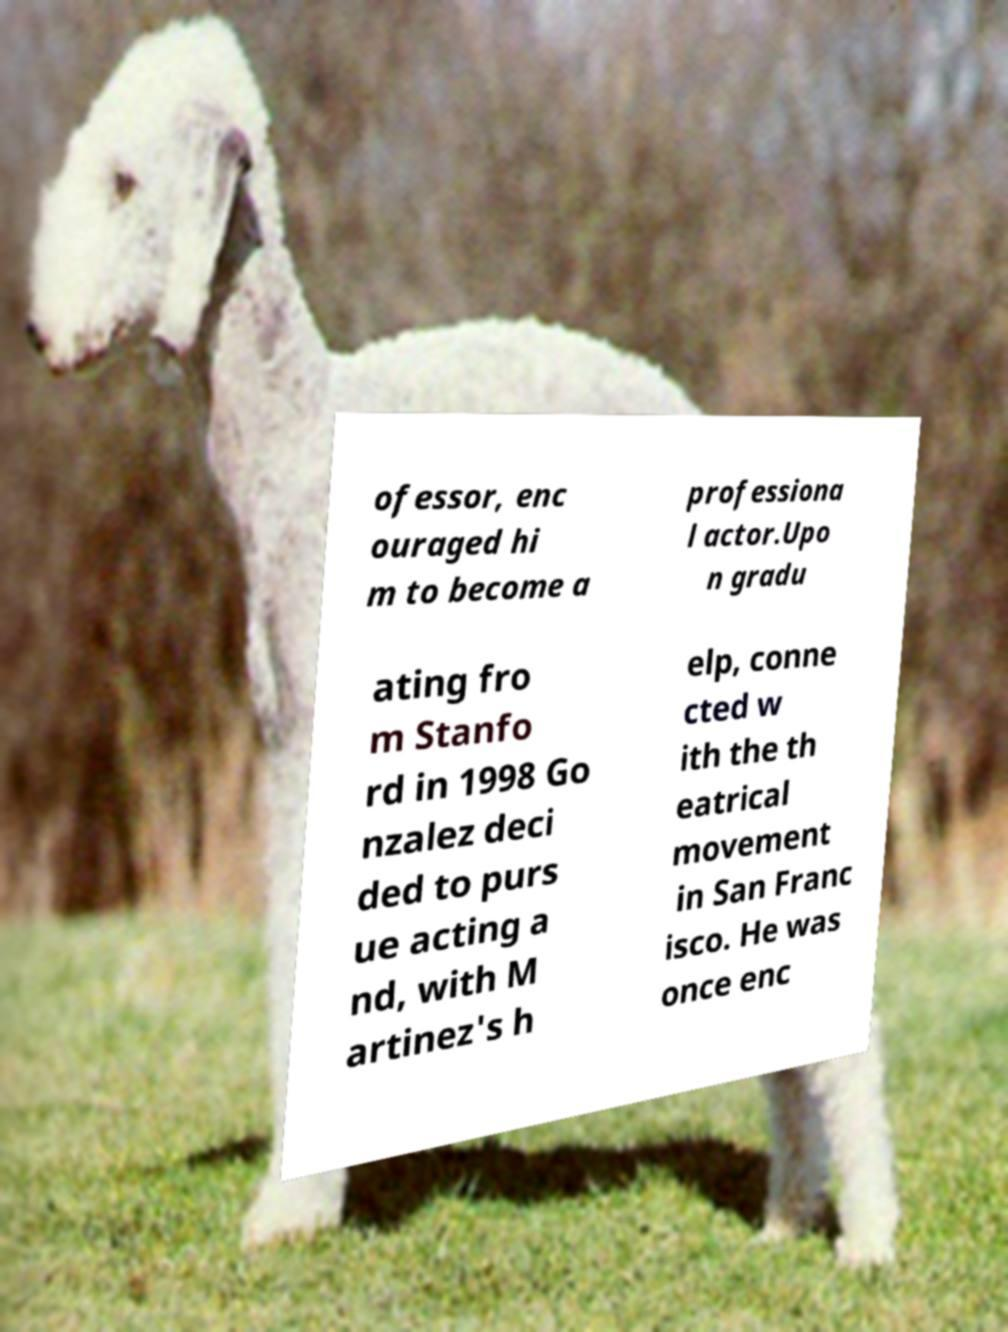Please identify and transcribe the text found in this image. ofessor, enc ouraged hi m to become a professiona l actor.Upo n gradu ating fro m Stanfo rd in 1998 Go nzalez deci ded to purs ue acting a nd, with M artinez's h elp, conne cted w ith the th eatrical movement in San Franc isco. He was once enc 